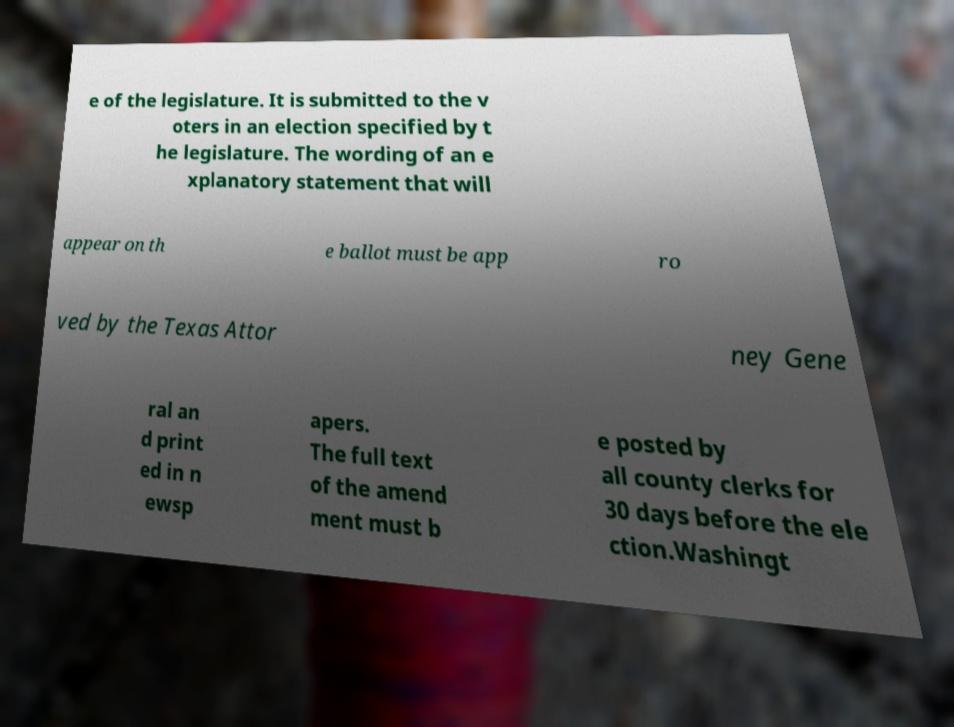For documentation purposes, I need the text within this image transcribed. Could you provide that? e of the legislature. It is submitted to the v oters in an election specified by t he legislature. The wording of an e xplanatory statement that will appear on th e ballot must be app ro ved by the Texas Attor ney Gene ral an d print ed in n ewsp apers. The full text of the amend ment must b e posted by all county clerks for 30 days before the ele ction.Washingt 